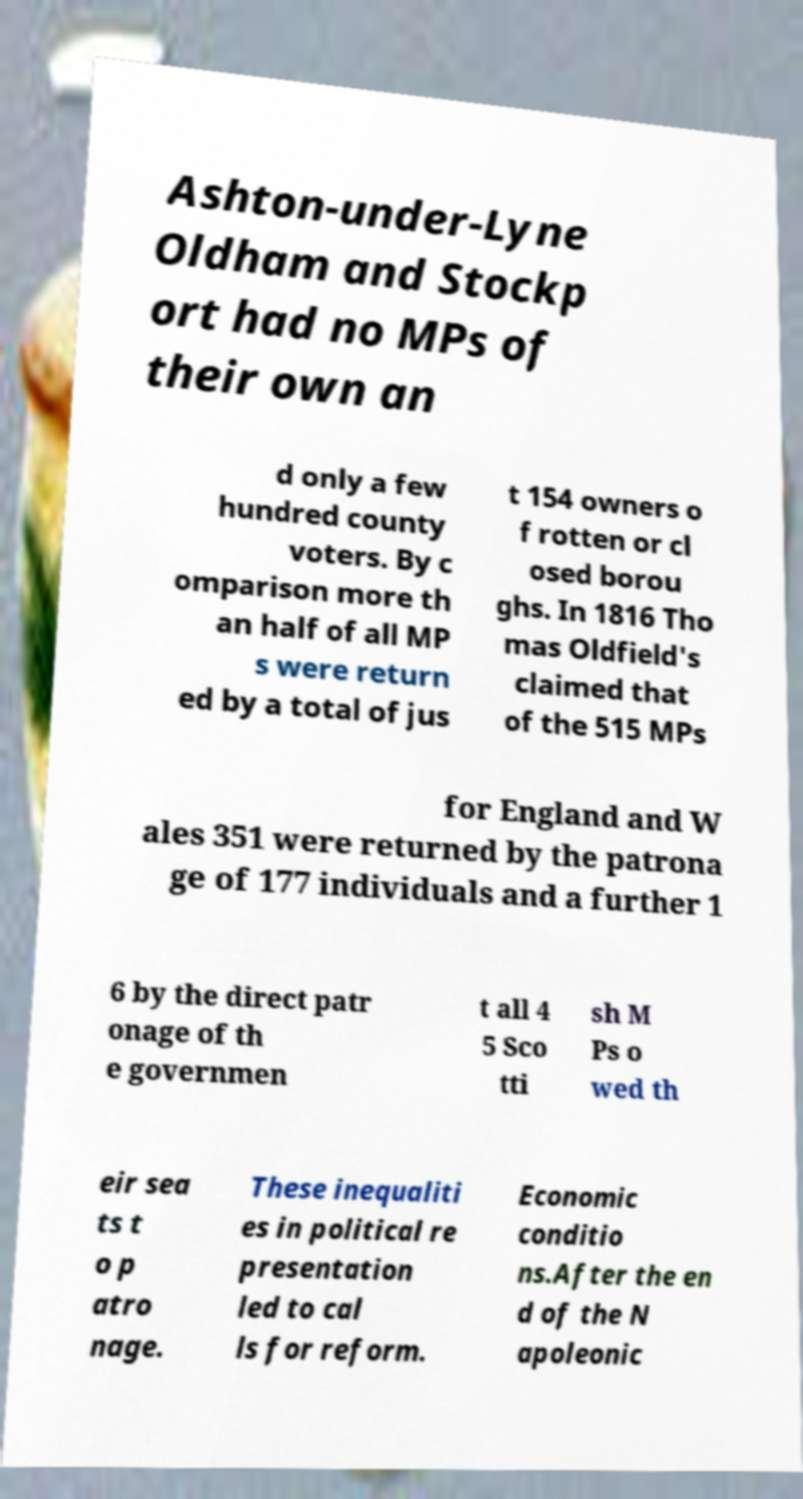There's text embedded in this image that I need extracted. Can you transcribe it verbatim? Ashton-under-Lyne Oldham and Stockp ort had no MPs of their own an d only a few hundred county voters. By c omparison more th an half of all MP s were return ed by a total of jus t 154 owners o f rotten or cl osed borou ghs. In 1816 Tho mas Oldfield's claimed that of the 515 MPs for England and W ales 351 were returned by the patrona ge of 177 individuals and a further 1 6 by the direct patr onage of th e governmen t all 4 5 Sco tti sh M Ps o wed th eir sea ts t o p atro nage. These inequaliti es in political re presentation led to cal ls for reform. Economic conditio ns.After the en d of the N apoleonic 